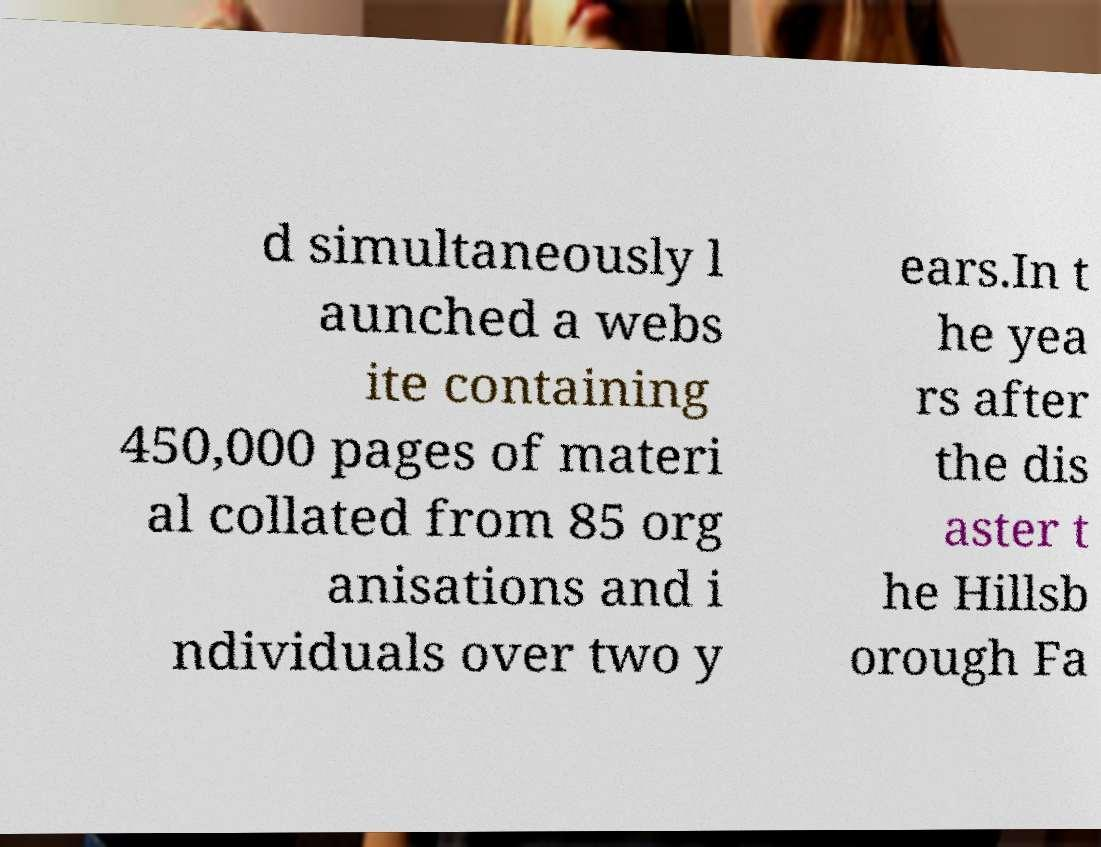I need the written content from this picture converted into text. Can you do that? d simultaneously l aunched a webs ite containing 450,000 pages of materi al collated from 85 org anisations and i ndividuals over two y ears.In t he yea rs after the dis aster t he Hillsb orough Fa 